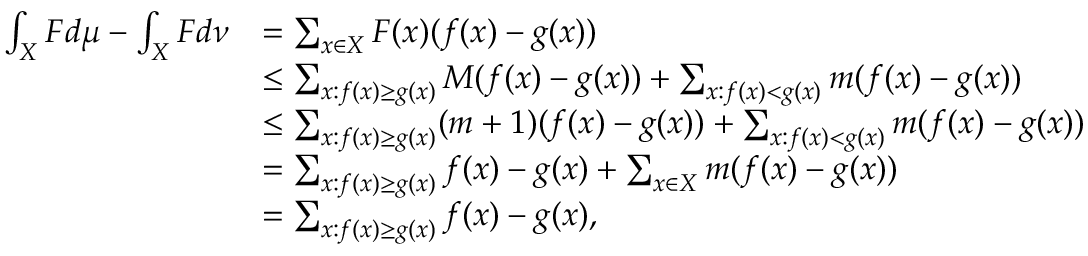Convert formula to latex. <formula><loc_0><loc_0><loc_500><loc_500>\begin{array} { r l } { \int _ { X } F d \mu - \int _ { X } F d \nu } & { = \sum _ { x \in X } F ( x ) ( f ( x ) - g ( x ) ) } \\ & { \leq \sum _ { x \colon f ( x ) \geq g ( x ) } M ( f ( x ) - g ( x ) ) + \sum _ { x \colon f ( x ) < g ( x ) } m ( f ( x ) - g ( x ) ) } \\ & { \leq \sum _ { x \colon f ( x ) \geq g ( x ) } ( m + 1 ) ( f ( x ) - g ( x ) ) + \sum _ { x \colon f ( x ) < g ( x ) } m ( f ( x ) - g ( x ) ) } \\ & { = \sum _ { x \colon f ( x ) \geq g ( x ) } f ( x ) - g ( x ) + \sum _ { x \in X } m ( f ( x ) - g ( x ) ) } \\ & { = \sum _ { x \colon f ( x ) \geq g ( x ) } f ( x ) - g ( x ) , } \end{array}</formula> 